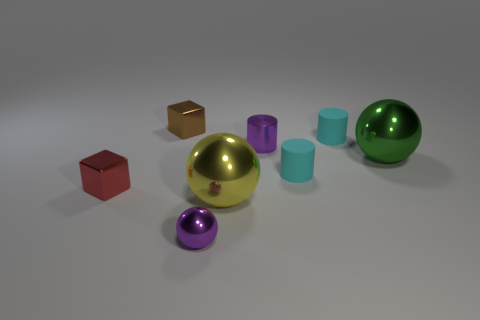Subtract all purple shiny cylinders. How many cylinders are left? 2 Add 1 red blocks. How many objects exist? 9 Subtract all yellow balls. How many cyan cylinders are left? 2 Subtract all green balls. How many balls are left? 2 Subtract 2 balls. How many balls are left? 1 Subtract all red spheres. Subtract all red cylinders. How many spheres are left? 3 Subtract all brown shiny cubes. Subtract all cyan matte cylinders. How many objects are left? 5 Add 3 small balls. How many small balls are left? 4 Add 3 tiny purple metal things. How many tiny purple metal things exist? 5 Subtract 0 purple blocks. How many objects are left? 8 